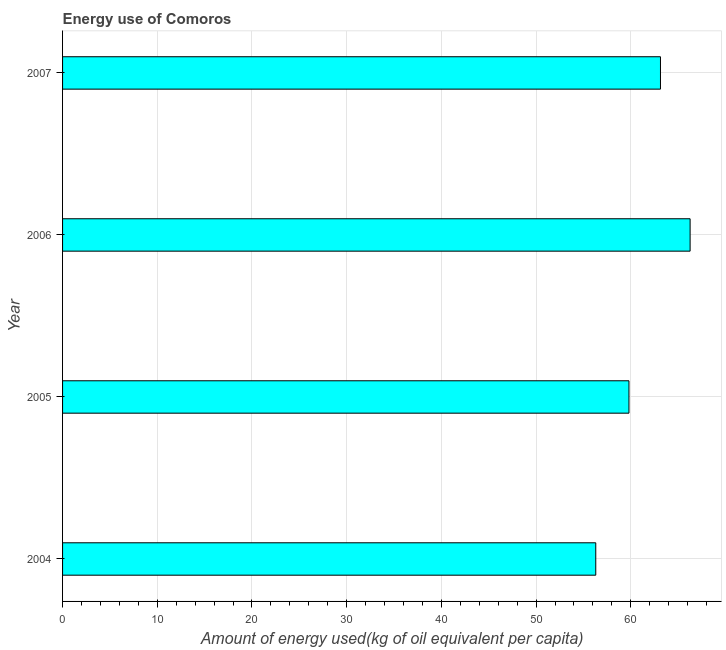Does the graph contain grids?
Give a very brief answer. Yes. What is the title of the graph?
Your response must be concise. Energy use of Comoros. What is the label or title of the X-axis?
Keep it short and to the point. Amount of energy used(kg of oil equivalent per capita). What is the amount of energy used in 2004?
Provide a short and direct response. 56.3. Across all years, what is the maximum amount of energy used?
Ensure brevity in your answer.  66.27. Across all years, what is the minimum amount of energy used?
Provide a succinct answer. 56.3. In which year was the amount of energy used maximum?
Keep it short and to the point. 2006. In which year was the amount of energy used minimum?
Provide a succinct answer. 2004. What is the sum of the amount of energy used?
Keep it short and to the point. 245.51. What is the difference between the amount of energy used in 2004 and 2005?
Ensure brevity in your answer.  -3.51. What is the average amount of energy used per year?
Your answer should be compact. 61.38. What is the median amount of energy used?
Your response must be concise. 61.47. Do a majority of the years between 2007 and 2004 (inclusive) have amount of energy used greater than 14 kg?
Provide a short and direct response. Yes. What is the ratio of the amount of energy used in 2004 to that in 2007?
Offer a terse response. 0.89. Is the amount of energy used in 2004 less than that in 2006?
Offer a terse response. Yes. What is the difference between the highest and the second highest amount of energy used?
Keep it short and to the point. 3.13. Is the sum of the amount of energy used in 2005 and 2007 greater than the maximum amount of energy used across all years?
Provide a succinct answer. Yes. What is the difference between the highest and the lowest amount of energy used?
Your response must be concise. 9.96. How many years are there in the graph?
Provide a short and direct response. 4. Are the values on the major ticks of X-axis written in scientific E-notation?
Your answer should be very brief. No. What is the Amount of energy used(kg of oil equivalent per capita) in 2004?
Offer a terse response. 56.3. What is the Amount of energy used(kg of oil equivalent per capita) of 2005?
Keep it short and to the point. 59.81. What is the Amount of energy used(kg of oil equivalent per capita) in 2006?
Ensure brevity in your answer.  66.27. What is the Amount of energy used(kg of oil equivalent per capita) of 2007?
Your response must be concise. 63.13. What is the difference between the Amount of energy used(kg of oil equivalent per capita) in 2004 and 2005?
Provide a short and direct response. -3.51. What is the difference between the Amount of energy used(kg of oil equivalent per capita) in 2004 and 2006?
Your answer should be compact. -9.96. What is the difference between the Amount of energy used(kg of oil equivalent per capita) in 2004 and 2007?
Offer a terse response. -6.83. What is the difference between the Amount of energy used(kg of oil equivalent per capita) in 2005 and 2006?
Make the answer very short. -6.46. What is the difference between the Amount of energy used(kg of oil equivalent per capita) in 2005 and 2007?
Your answer should be very brief. -3.33. What is the difference between the Amount of energy used(kg of oil equivalent per capita) in 2006 and 2007?
Offer a very short reply. 3.13. What is the ratio of the Amount of energy used(kg of oil equivalent per capita) in 2004 to that in 2005?
Make the answer very short. 0.94. What is the ratio of the Amount of energy used(kg of oil equivalent per capita) in 2004 to that in 2006?
Offer a terse response. 0.85. What is the ratio of the Amount of energy used(kg of oil equivalent per capita) in 2004 to that in 2007?
Make the answer very short. 0.89. What is the ratio of the Amount of energy used(kg of oil equivalent per capita) in 2005 to that in 2006?
Your response must be concise. 0.9. What is the ratio of the Amount of energy used(kg of oil equivalent per capita) in 2005 to that in 2007?
Offer a very short reply. 0.95. What is the ratio of the Amount of energy used(kg of oil equivalent per capita) in 2006 to that in 2007?
Your answer should be very brief. 1.05. 